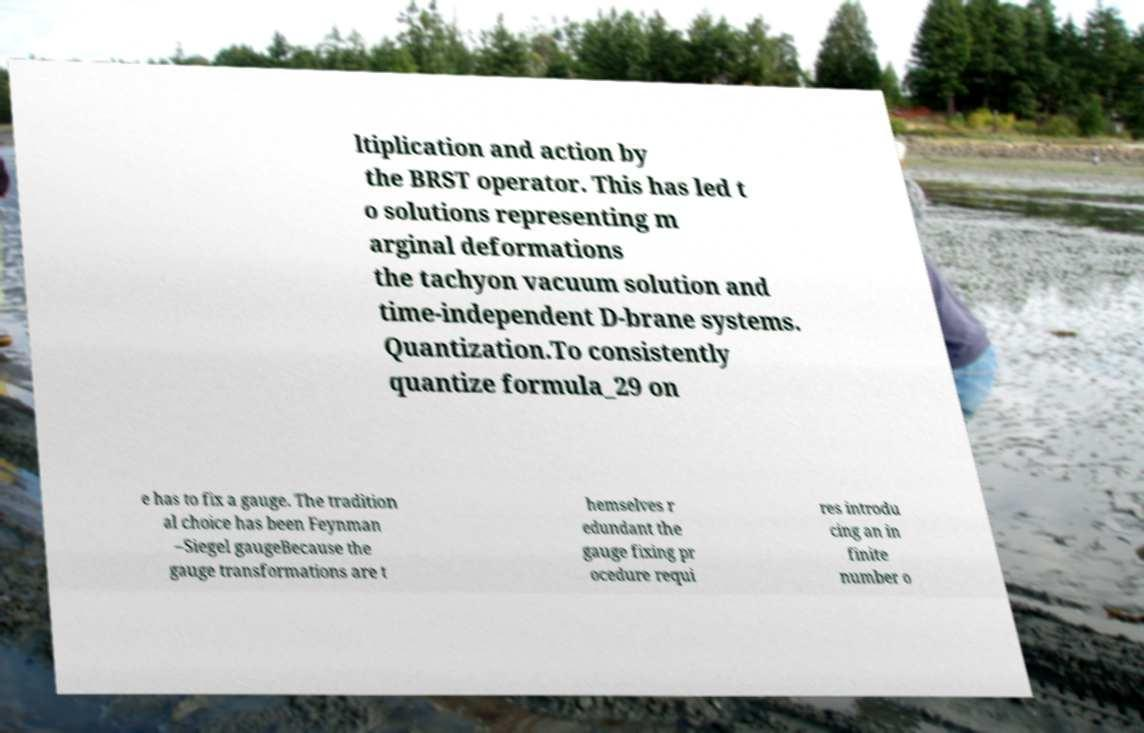What messages or text are displayed in this image? I need them in a readable, typed format. ltiplication and action by the BRST operator. This has led t o solutions representing m arginal deformations the tachyon vacuum solution and time-independent D-brane systems. Quantization.To consistently quantize formula_29 on e has to fix a gauge. The tradition al choice has been Feynman –Siegel gaugeBecause the gauge transformations are t hemselves r edundant the gauge fixing pr ocedure requi res introdu cing an in finite number o 